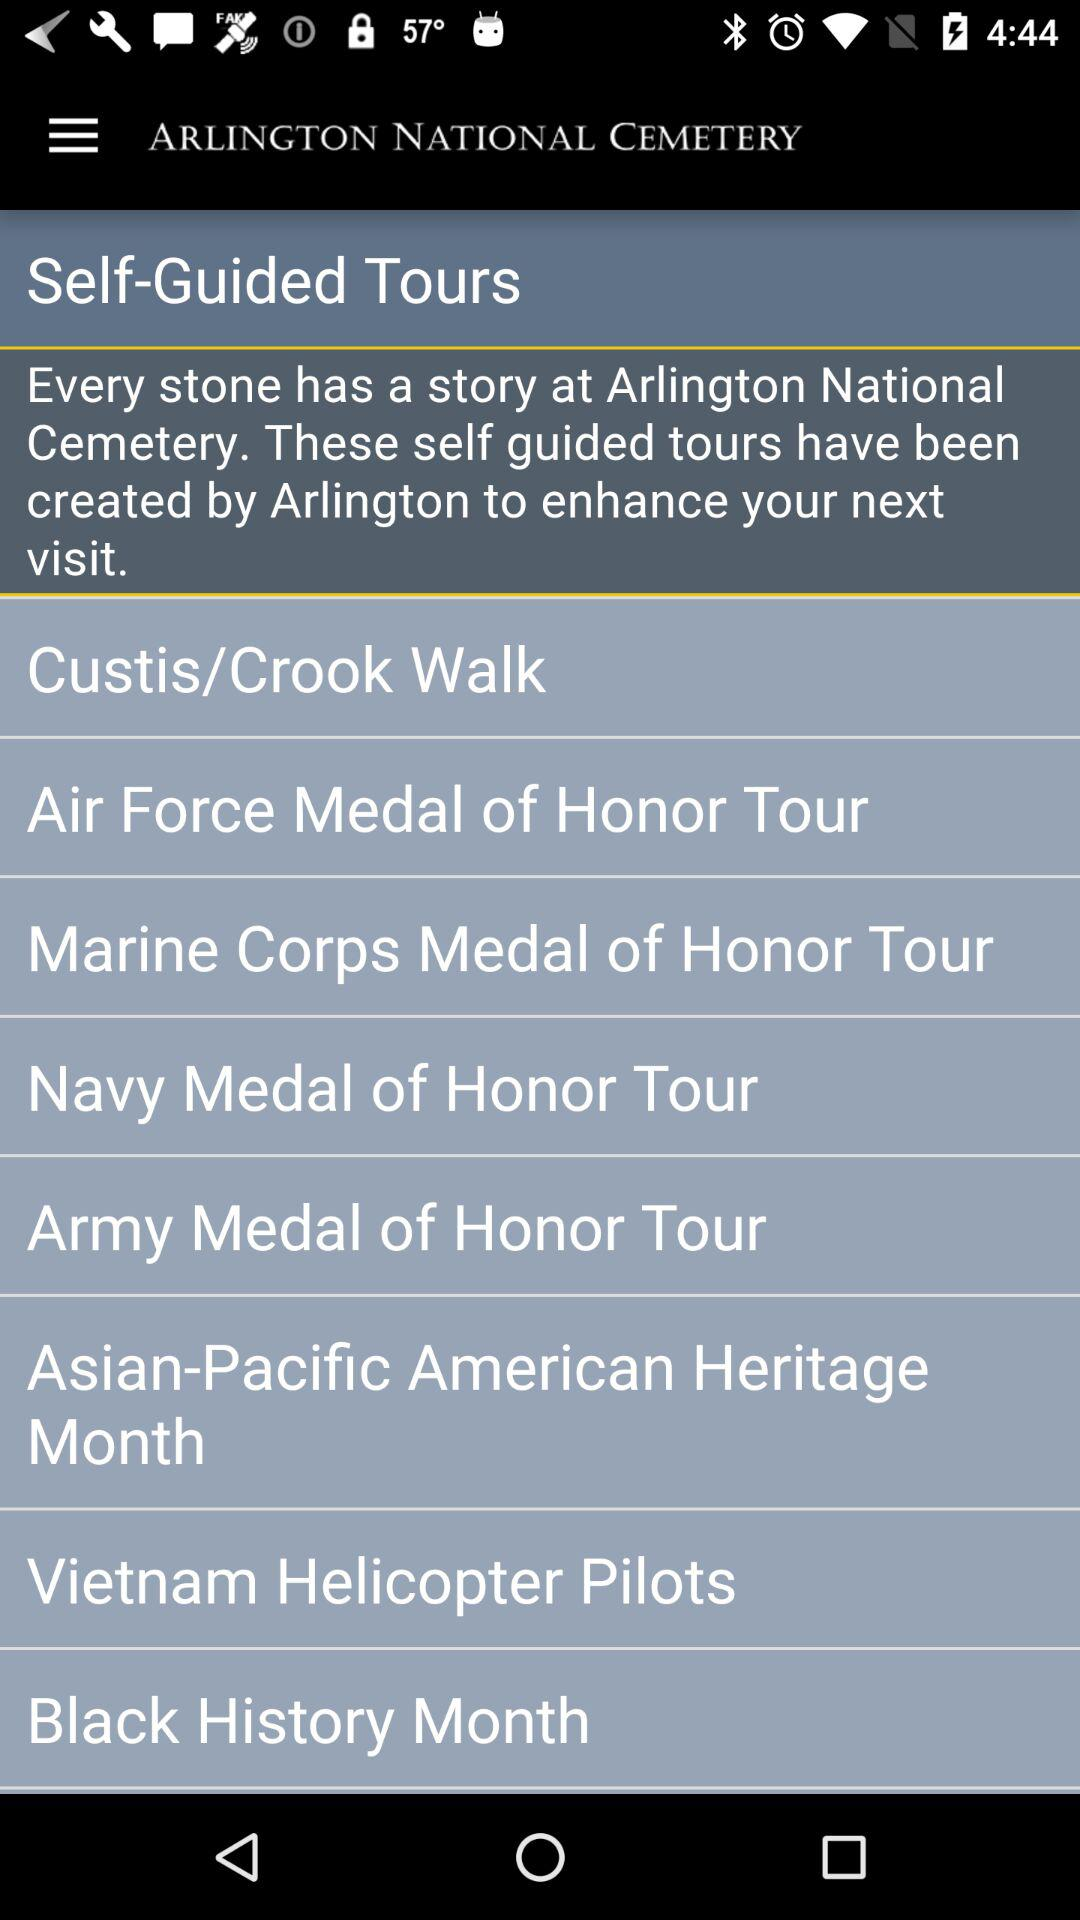How much is the self-guided Air Force tour?
When the provided information is insufficient, respond with <no answer>. <no answer> 